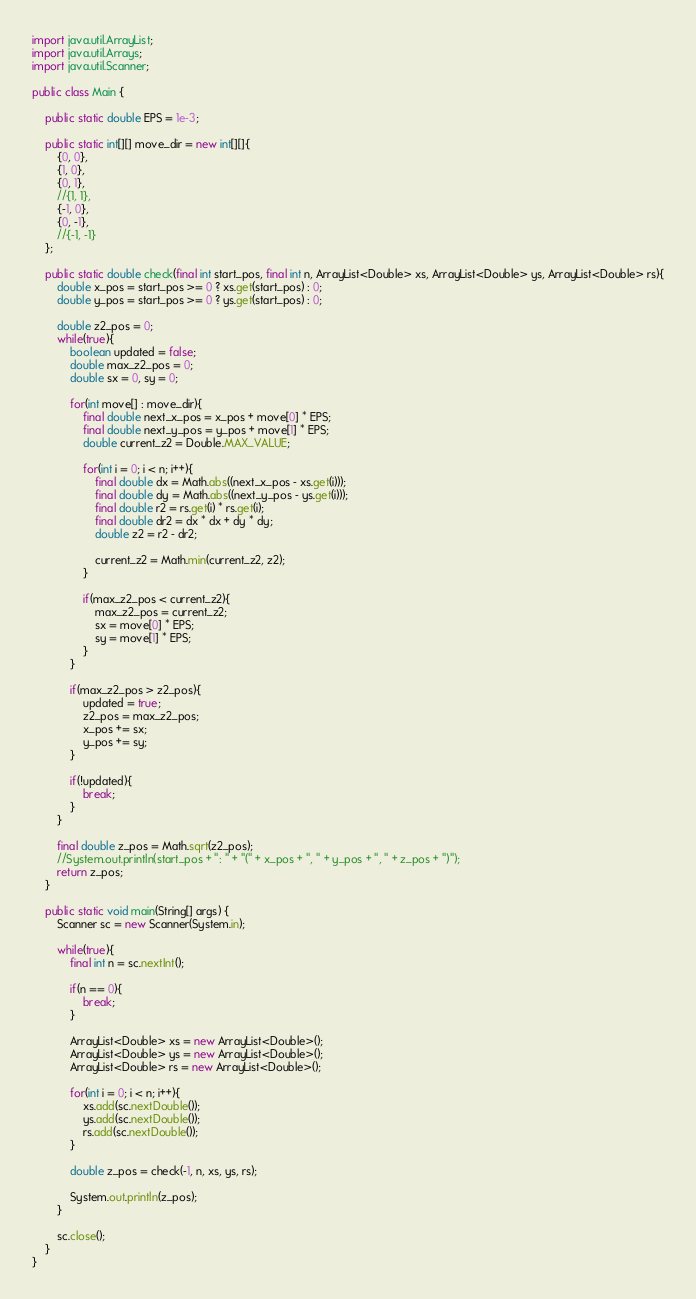<code> <loc_0><loc_0><loc_500><loc_500><_Java_>import java.util.ArrayList;
import java.util.Arrays;
import java.util.Scanner;

public class Main {
	
	public static double EPS = 1e-3;
	
	public static int[][] move_dir = new int[][]{
		{0, 0},
		{1, 0},
		{0, 1},
		//{1, 1},
		{-1, 0},
		{0, -1},
		//{-1, -1}
	};
	
	public static double check(final int start_pos, final int n, ArrayList<Double> xs, ArrayList<Double> ys, ArrayList<Double> rs){
		double x_pos = start_pos >= 0 ? xs.get(start_pos) : 0;
		double y_pos = start_pos >= 0 ? ys.get(start_pos) : 0;
		
		double z2_pos = 0;
		while(true){
			boolean updated = false;
			double max_z2_pos = 0;
			double sx = 0, sy = 0;
			
			for(int move[] : move_dir){
				final double next_x_pos = x_pos + move[0] * EPS;
				final double next_y_pos = y_pos + move[1] * EPS;
				double current_z2 = Double.MAX_VALUE;
				
				for(int i = 0; i < n; i++){
					final double dx = Math.abs((next_x_pos - xs.get(i)));
					final double dy = Math.abs((next_y_pos - ys.get(i)));
					final double r2 = rs.get(i) * rs.get(i);
					final double dr2 = dx * dx + dy * dy;
					double z2 = r2 - dr2;
					
					current_z2 = Math.min(current_z2, z2);
				}
				
				if(max_z2_pos < current_z2){
					max_z2_pos = current_z2;
					sx = move[0] * EPS;
					sy = move[1] * EPS;
				}
			}
			
			if(max_z2_pos > z2_pos){
				updated = true;
				z2_pos = max_z2_pos;
				x_pos += sx;
				y_pos += sy;
			}
			
			if(!updated){
				break;
			}
		}
		
		final double z_pos = Math.sqrt(z2_pos);
		//System.out.println(start_pos + ": " + "(" + x_pos + ", " + y_pos + ", " + z_pos + ")");
		return z_pos;
	}
	
	public static void main(String[] args) {
		Scanner sc = new Scanner(System.in);
	
		while(true){
			final int n = sc.nextInt();
		
			if(n == 0){
				break;
			}
			
			ArrayList<Double> xs = new ArrayList<Double>();
			ArrayList<Double> ys = new ArrayList<Double>();
			ArrayList<Double> rs = new ArrayList<Double>();
			
			for(int i = 0; i < n; i++){
				xs.add(sc.nextDouble());
				ys.add(sc.nextDouble());
				rs.add(sc.nextDouble());
			}
			
			double z_pos = check(-1, n, xs, ys, rs);
			
			System.out.println(z_pos);
		}
		
		sc.close();
	}
}</code> 